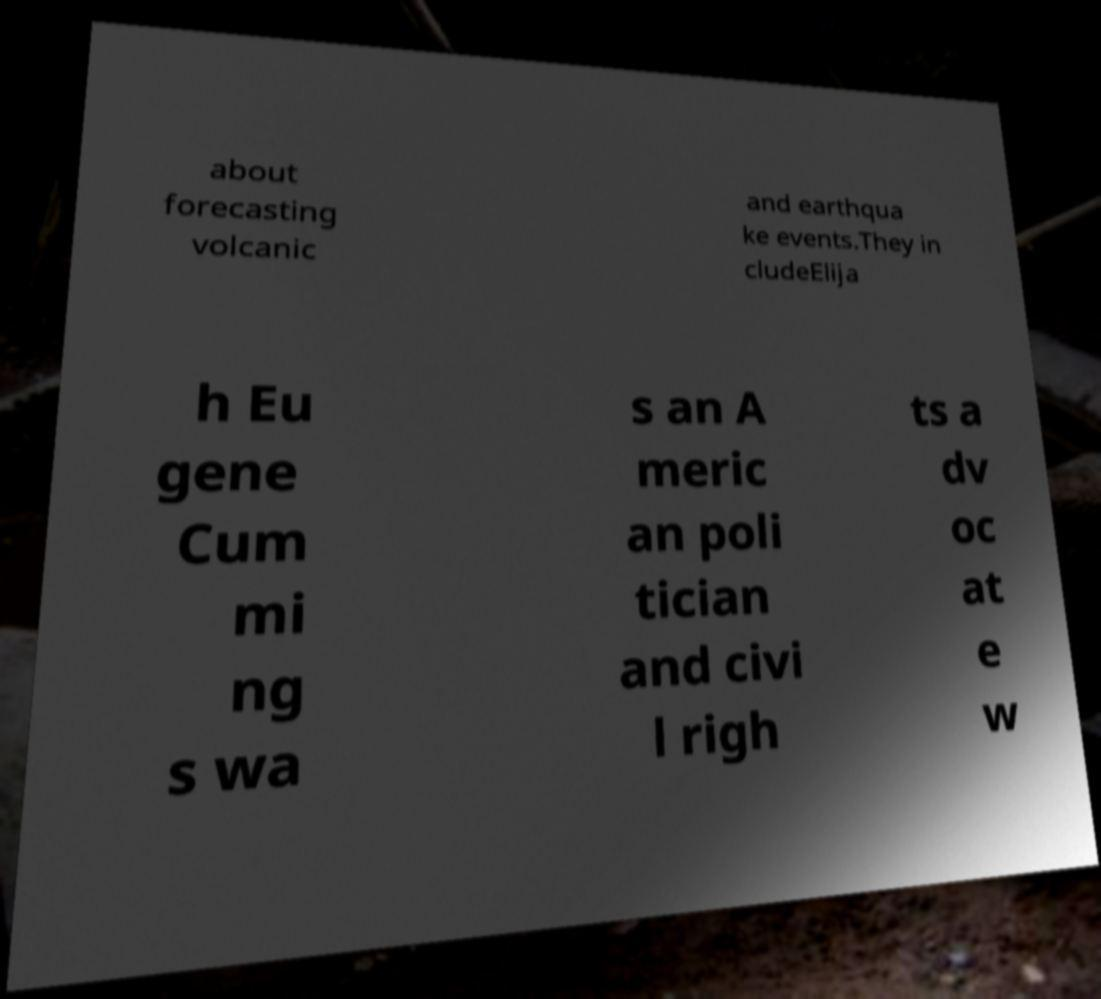Can you read and provide the text displayed in the image?This photo seems to have some interesting text. Can you extract and type it out for me? about forecasting volcanic and earthqua ke events.They in cludeElija h Eu gene Cum mi ng s wa s an A meric an poli tician and civi l righ ts a dv oc at e w 